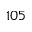Convert formula to latex. <formula><loc_0><loc_0><loc_500><loc_500>1 0 5</formula> 